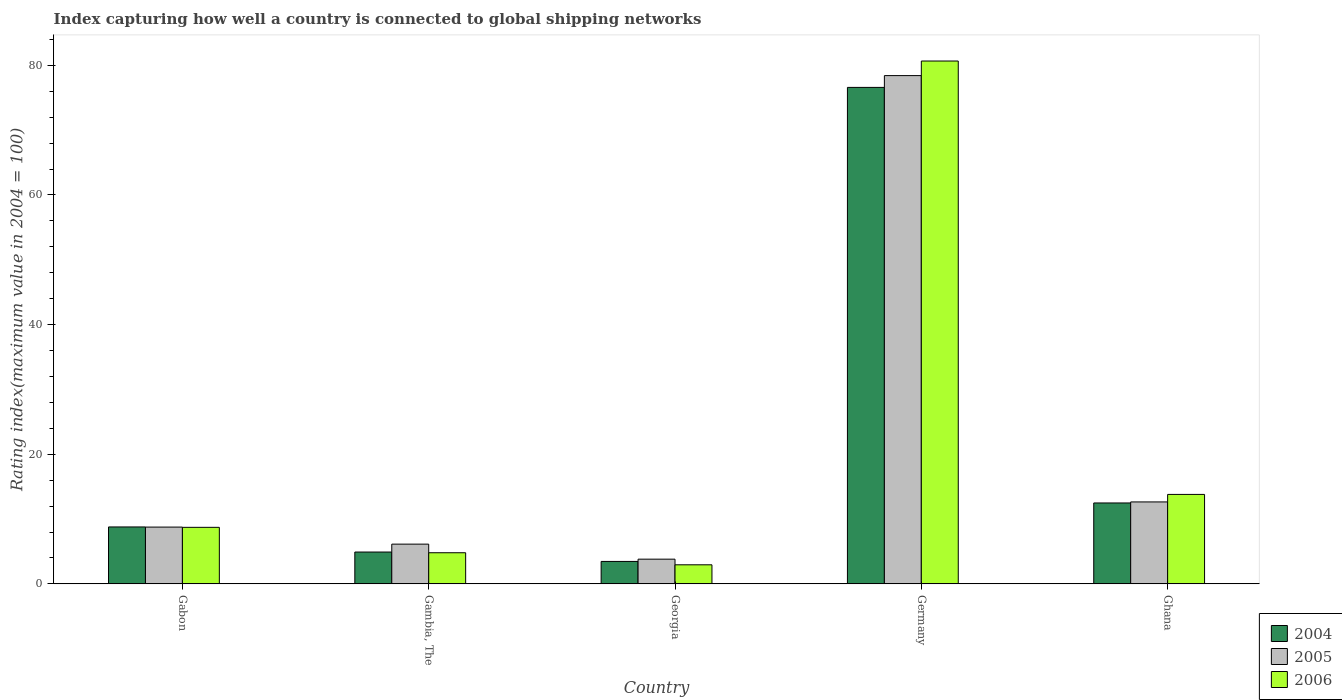How many different coloured bars are there?
Your answer should be compact. 3. How many bars are there on the 1st tick from the right?
Offer a terse response. 3. What is the label of the 1st group of bars from the left?
Your response must be concise. Gabon. What is the rating index in 2005 in Gabon?
Ensure brevity in your answer.  8.76. Across all countries, what is the maximum rating index in 2006?
Your response must be concise. 80.66. Across all countries, what is the minimum rating index in 2005?
Your answer should be very brief. 3.81. In which country was the rating index in 2005 maximum?
Your response must be concise. Germany. In which country was the rating index in 2005 minimum?
Your answer should be very brief. Georgia. What is the total rating index in 2006 in the graph?
Make the answer very short. 110.92. What is the difference between the rating index in 2004 in Gabon and that in Ghana?
Provide a short and direct response. -3.7. What is the difference between the rating index in 2004 in Georgia and the rating index in 2005 in Ghana?
Keep it short and to the point. -9.18. What is the average rating index in 2004 per country?
Provide a succinct answer. 21.24. What is the difference between the rating index of/in 2005 and rating index of/in 2006 in Gambia, The?
Your response must be concise. 1.33. What is the ratio of the rating index in 2005 in Gambia, The to that in Ghana?
Keep it short and to the point. 0.48. Is the rating index in 2006 in Gabon less than that in Germany?
Make the answer very short. Yes. Is the difference between the rating index in 2005 in Gambia, The and Georgia greater than the difference between the rating index in 2006 in Gambia, The and Georgia?
Offer a very short reply. Yes. What is the difference between the highest and the second highest rating index in 2005?
Offer a very short reply. -3.88. What is the difference between the highest and the lowest rating index in 2004?
Offer a very short reply. 73.13. Is the sum of the rating index in 2006 in Gabon and Germany greater than the maximum rating index in 2005 across all countries?
Provide a succinct answer. Yes. What does the 1st bar from the left in Germany represents?
Keep it short and to the point. 2004. Is it the case that in every country, the sum of the rating index in 2005 and rating index in 2006 is greater than the rating index in 2004?
Your answer should be very brief. Yes. How many bars are there?
Provide a succinct answer. 15. Are all the bars in the graph horizontal?
Your answer should be compact. No. How many countries are there in the graph?
Provide a short and direct response. 5. What is the difference between two consecutive major ticks on the Y-axis?
Provide a succinct answer. 20. Are the values on the major ticks of Y-axis written in scientific E-notation?
Your answer should be compact. No. Does the graph contain grids?
Offer a very short reply. No. Where does the legend appear in the graph?
Keep it short and to the point. Bottom right. How many legend labels are there?
Keep it short and to the point. 3. What is the title of the graph?
Offer a very short reply. Index capturing how well a country is connected to global shipping networks. What is the label or title of the X-axis?
Your response must be concise. Country. What is the label or title of the Y-axis?
Offer a terse response. Rating index(maximum value in 2004 = 100). What is the Rating index(maximum value in 2004 = 100) in 2004 in Gabon?
Keep it short and to the point. 8.78. What is the Rating index(maximum value in 2004 = 100) in 2005 in Gabon?
Provide a short and direct response. 8.76. What is the Rating index(maximum value in 2004 = 100) in 2006 in Gabon?
Your answer should be very brief. 8.72. What is the Rating index(maximum value in 2004 = 100) of 2004 in Gambia, The?
Offer a terse response. 4.91. What is the Rating index(maximum value in 2004 = 100) of 2005 in Gambia, The?
Provide a succinct answer. 6.13. What is the Rating index(maximum value in 2004 = 100) in 2004 in Georgia?
Keep it short and to the point. 3.46. What is the Rating index(maximum value in 2004 = 100) of 2005 in Georgia?
Ensure brevity in your answer.  3.81. What is the Rating index(maximum value in 2004 = 100) of 2006 in Georgia?
Offer a terse response. 2.94. What is the Rating index(maximum value in 2004 = 100) of 2004 in Germany?
Offer a very short reply. 76.59. What is the Rating index(maximum value in 2004 = 100) of 2005 in Germany?
Offer a very short reply. 78.41. What is the Rating index(maximum value in 2004 = 100) in 2006 in Germany?
Give a very brief answer. 80.66. What is the Rating index(maximum value in 2004 = 100) of 2004 in Ghana?
Give a very brief answer. 12.48. What is the Rating index(maximum value in 2004 = 100) of 2005 in Ghana?
Ensure brevity in your answer.  12.64. Across all countries, what is the maximum Rating index(maximum value in 2004 = 100) in 2004?
Provide a short and direct response. 76.59. Across all countries, what is the maximum Rating index(maximum value in 2004 = 100) in 2005?
Make the answer very short. 78.41. Across all countries, what is the maximum Rating index(maximum value in 2004 = 100) in 2006?
Make the answer very short. 80.66. Across all countries, what is the minimum Rating index(maximum value in 2004 = 100) in 2004?
Your answer should be compact. 3.46. Across all countries, what is the minimum Rating index(maximum value in 2004 = 100) of 2005?
Offer a very short reply. 3.81. Across all countries, what is the minimum Rating index(maximum value in 2004 = 100) in 2006?
Give a very brief answer. 2.94. What is the total Rating index(maximum value in 2004 = 100) of 2004 in the graph?
Your answer should be compact. 106.22. What is the total Rating index(maximum value in 2004 = 100) in 2005 in the graph?
Your response must be concise. 109.75. What is the total Rating index(maximum value in 2004 = 100) of 2006 in the graph?
Keep it short and to the point. 110.92. What is the difference between the Rating index(maximum value in 2004 = 100) of 2004 in Gabon and that in Gambia, The?
Offer a terse response. 3.87. What is the difference between the Rating index(maximum value in 2004 = 100) in 2005 in Gabon and that in Gambia, The?
Your answer should be compact. 2.63. What is the difference between the Rating index(maximum value in 2004 = 100) in 2006 in Gabon and that in Gambia, The?
Your response must be concise. 3.92. What is the difference between the Rating index(maximum value in 2004 = 100) in 2004 in Gabon and that in Georgia?
Your answer should be very brief. 5.32. What is the difference between the Rating index(maximum value in 2004 = 100) of 2005 in Gabon and that in Georgia?
Give a very brief answer. 4.95. What is the difference between the Rating index(maximum value in 2004 = 100) of 2006 in Gabon and that in Georgia?
Your response must be concise. 5.78. What is the difference between the Rating index(maximum value in 2004 = 100) in 2004 in Gabon and that in Germany?
Your response must be concise. -67.81. What is the difference between the Rating index(maximum value in 2004 = 100) of 2005 in Gabon and that in Germany?
Provide a short and direct response. -69.65. What is the difference between the Rating index(maximum value in 2004 = 100) of 2006 in Gabon and that in Germany?
Your answer should be very brief. -71.94. What is the difference between the Rating index(maximum value in 2004 = 100) in 2004 in Gabon and that in Ghana?
Your answer should be very brief. -3.7. What is the difference between the Rating index(maximum value in 2004 = 100) in 2005 in Gabon and that in Ghana?
Give a very brief answer. -3.88. What is the difference between the Rating index(maximum value in 2004 = 100) in 2006 in Gabon and that in Ghana?
Ensure brevity in your answer.  -5.08. What is the difference between the Rating index(maximum value in 2004 = 100) of 2004 in Gambia, The and that in Georgia?
Offer a terse response. 1.45. What is the difference between the Rating index(maximum value in 2004 = 100) of 2005 in Gambia, The and that in Georgia?
Provide a short and direct response. 2.32. What is the difference between the Rating index(maximum value in 2004 = 100) of 2006 in Gambia, The and that in Georgia?
Your answer should be very brief. 1.86. What is the difference between the Rating index(maximum value in 2004 = 100) of 2004 in Gambia, The and that in Germany?
Make the answer very short. -71.68. What is the difference between the Rating index(maximum value in 2004 = 100) in 2005 in Gambia, The and that in Germany?
Ensure brevity in your answer.  -72.28. What is the difference between the Rating index(maximum value in 2004 = 100) of 2006 in Gambia, The and that in Germany?
Ensure brevity in your answer.  -75.86. What is the difference between the Rating index(maximum value in 2004 = 100) in 2004 in Gambia, The and that in Ghana?
Your response must be concise. -7.57. What is the difference between the Rating index(maximum value in 2004 = 100) in 2005 in Gambia, The and that in Ghana?
Ensure brevity in your answer.  -6.51. What is the difference between the Rating index(maximum value in 2004 = 100) in 2006 in Gambia, The and that in Ghana?
Give a very brief answer. -9. What is the difference between the Rating index(maximum value in 2004 = 100) of 2004 in Georgia and that in Germany?
Ensure brevity in your answer.  -73.13. What is the difference between the Rating index(maximum value in 2004 = 100) in 2005 in Georgia and that in Germany?
Offer a very short reply. -74.6. What is the difference between the Rating index(maximum value in 2004 = 100) in 2006 in Georgia and that in Germany?
Provide a short and direct response. -77.72. What is the difference between the Rating index(maximum value in 2004 = 100) in 2004 in Georgia and that in Ghana?
Your answer should be very brief. -9.02. What is the difference between the Rating index(maximum value in 2004 = 100) in 2005 in Georgia and that in Ghana?
Ensure brevity in your answer.  -8.83. What is the difference between the Rating index(maximum value in 2004 = 100) in 2006 in Georgia and that in Ghana?
Make the answer very short. -10.86. What is the difference between the Rating index(maximum value in 2004 = 100) in 2004 in Germany and that in Ghana?
Provide a succinct answer. 64.11. What is the difference between the Rating index(maximum value in 2004 = 100) of 2005 in Germany and that in Ghana?
Your answer should be very brief. 65.77. What is the difference between the Rating index(maximum value in 2004 = 100) of 2006 in Germany and that in Ghana?
Provide a short and direct response. 66.86. What is the difference between the Rating index(maximum value in 2004 = 100) of 2004 in Gabon and the Rating index(maximum value in 2004 = 100) of 2005 in Gambia, The?
Ensure brevity in your answer.  2.65. What is the difference between the Rating index(maximum value in 2004 = 100) of 2004 in Gabon and the Rating index(maximum value in 2004 = 100) of 2006 in Gambia, The?
Provide a short and direct response. 3.98. What is the difference between the Rating index(maximum value in 2004 = 100) in 2005 in Gabon and the Rating index(maximum value in 2004 = 100) in 2006 in Gambia, The?
Keep it short and to the point. 3.96. What is the difference between the Rating index(maximum value in 2004 = 100) of 2004 in Gabon and the Rating index(maximum value in 2004 = 100) of 2005 in Georgia?
Provide a succinct answer. 4.97. What is the difference between the Rating index(maximum value in 2004 = 100) of 2004 in Gabon and the Rating index(maximum value in 2004 = 100) of 2006 in Georgia?
Offer a terse response. 5.84. What is the difference between the Rating index(maximum value in 2004 = 100) of 2005 in Gabon and the Rating index(maximum value in 2004 = 100) of 2006 in Georgia?
Provide a succinct answer. 5.82. What is the difference between the Rating index(maximum value in 2004 = 100) in 2004 in Gabon and the Rating index(maximum value in 2004 = 100) in 2005 in Germany?
Offer a terse response. -69.63. What is the difference between the Rating index(maximum value in 2004 = 100) of 2004 in Gabon and the Rating index(maximum value in 2004 = 100) of 2006 in Germany?
Keep it short and to the point. -71.88. What is the difference between the Rating index(maximum value in 2004 = 100) of 2005 in Gabon and the Rating index(maximum value in 2004 = 100) of 2006 in Germany?
Keep it short and to the point. -71.9. What is the difference between the Rating index(maximum value in 2004 = 100) of 2004 in Gabon and the Rating index(maximum value in 2004 = 100) of 2005 in Ghana?
Offer a very short reply. -3.86. What is the difference between the Rating index(maximum value in 2004 = 100) in 2004 in Gabon and the Rating index(maximum value in 2004 = 100) in 2006 in Ghana?
Provide a succinct answer. -5.02. What is the difference between the Rating index(maximum value in 2004 = 100) in 2005 in Gabon and the Rating index(maximum value in 2004 = 100) in 2006 in Ghana?
Provide a short and direct response. -5.04. What is the difference between the Rating index(maximum value in 2004 = 100) in 2004 in Gambia, The and the Rating index(maximum value in 2004 = 100) in 2006 in Georgia?
Offer a terse response. 1.97. What is the difference between the Rating index(maximum value in 2004 = 100) in 2005 in Gambia, The and the Rating index(maximum value in 2004 = 100) in 2006 in Georgia?
Your answer should be very brief. 3.19. What is the difference between the Rating index(maximum value in 2004 = 100) of 2004 in Gambia, The and the Rating index(maximum value in 2004 = 100) of 2005 in Germany?
Make the answer very short. -73.5. What is the difference between the Rating index(maximum value in 2004 = 100) of 2004 in Gambia, The and the Rating index(maximum value in 2004 = 100) of 2006 in Germany?
Make the answer very short. -75.75. What is the difference between the Rating index(maximum value in 2004 = 100) of 2005 in Gambia, The and the Rating index(maximum value in 2004 = 100) of 2006 in Germany?
Offer a very short reply. -74.53. What is the difference between the Rating index(maximum value in 2004 = 100) of 2004 in Gambia, The and the Rating index(maximum value in 2004 = 100) of 2005 in Ghana?
Give a very brief answer. -7.73. What is the difference between the Rating index(maximum value in 2004 = 100) of 2004 in Gambia, The and the Rating index(maximum value in 2004 = 100) of 2006 in Ghana?
Offer a terse response. -8.89. What is the difference between the Rating index(maximum value in 2004 = 100) in 2005 in Gambia, The and the Rating index(maximum value in 2004 = 100) in 2006 in Ghana?
Give a very brief answer. -7.67. What is the difference between the Rating index(maximum value in 2004 = 100) in 2004 in Georgia and the Rating index(maximum value in 2004 = 100) in 2005 in Germany?
Give a very brief answer. -74.95. What is the difference between the Rating index(maximum value in 2004 = 100) in 2004 in Georgia and the Rating index(maximum value in 2004 = 100) in 2006 in Germany?
Provide a succinct answer. -77.2. What is the difference between the Rating index(maximum value in 2004 = 100) in 2005 in Georgia and the Rating index(maximum value in 2004 = 100) in 2006 in Germany?
Your response must be concise. -76.85. What is the difference between the Rating index(maximum value in 2004 = 100) in 2004 in Georgia and the Rating index(maximum value in 2004 = 100) in 2005 in Ghana?
Your answer should be very brief. -9.18. What is the difference between the Rating index(maximum value in 2004 = 100) in 2004 in Georgia and the Rating index(maximum value in 2004 = 100) in 2006 in Ghana?
Provide a succinct answer. -10.34. What is the difference between the Rating index(maximum value in 2004 = 100) in 2005 in Georgia and the Rating index(maximum value in 2004 = 100) in 2006 in Ghana?
Offer a very short reply. -9.99. What is the difference between the Rating index(maximum value in 2004 = 100) in 2004 in Germany and the Rating index(maximum value in 2004 = 100) in 2005 in Ghana?
Offer a terse response. 63.95. What is the difference between the Rating index(maximum value in 2004 = 100) of 2004 in Germany and the Rating index(maximum value in 2004 = 100) of 2006 in Ghana?
Provide a short and direct response. 62.79. What is the difference between the Rating index(maximum value in 2004 = 100) in 2005 in Germany and the Rating index(maximum value in 2004 = 100) in 2006 in Ghana?
Provide a succinct answer. 64.61. What is the average Rating index(maximum value in 2004 = 100) in 2004 per country?
Make the answer very short. 21.24. What is the average Rating index(maximum value in 2004 = 100) in 2005 per country?
Your answer should be compact. 21.95. What is the average Rating index(maximum value in 2004 = 100) in 2006 per country?
Your answer should be compact. 22.18. What is the difference between the Rating index(maximum value in 2004 = 100) in 2004 and Rating index(maximum value in 2004 = 100) in 2005 in Gambia, The?
Your response must be concise. -1.22. What is the difference between the Rating index(maximum value in 2004 = 100) of 2004 and Rating index(maximum value in 2004 = 100) of 2006 in Gambia, The?
Ensure brevity in your answer.  0.11. What is the difference between the Rating index(maximum value in 2004 = 100) in 2005 and Rating index(maximum value in 2004 = 100) in 2006 in Gambia, The?
Your answer should be compact. 1.33. What is the difference between the Rating index(maximum value in 2004 = 100) in 2004 and Rating index(maximum value in 2004 = 100) in 2005 in Georgia?
Your answer should be compact. -0.35. What is the difference between the Rating index(maximum value in 2004 = 100) in 2004 and Rating index(maximum value in 2004 = 100) in 2006 in Georgia?
Offer a very short reply. 0.52. What is the difference between the Rating index(maximum value in 2004 = 100) of 2005 and Rating index(maximum value in 2004 = 100) of 2006 in Georgia?
Keep it short and to the point. 0.87. What is the difference between the Rating index(maximum value in 2004 = 100) in 2004 and Rating index(maximum value in 2004 = 100) in 2005 in Germany?
Your answer should be very brief. -1.82. What is the difference between the Rating index(maximum value in 2004 = 100) of 2004 and Rating index(maximum value in 2004 = 100) of 2006 in Germany?
Ensure brevity in your answer.  -4.07. What is the difference between the Rating index(maximum value in 2004 = 100) of 2005 and Rating index(maximum value in 2004 = 100) of 2006 in Germany?
Give a very brief answer. -2.25. What is the difference between the Rating index(maximum value in 2004 = 100) of 2004 and Rating index(maximum value in 2004 = 100) of 2005 in Ghana?
Your response must be concise. -0.16. What is the difference between the Rating index(maximum value in 2004 = 100) of 2004 and Rating index(maximum value in 2004 = 100) of 2006 in Ghana?
Provide a short and direct response. -1.32. What is the difference between the Rating index(maximum value in 2004 = 100) of 2005 and Rating index(maximum value in 2004 = 100) of 2006 in Ghana?
Your answer should be compact. -1.16. What is the ratio of the Rating index(maximum value in 2004 = 100) in 2004 in Gabon to that in Gambia, The?
Keep it short and to the point. 1.79. What is the ratio of the Rating index(maximum value in 2004 = 100) of 2005 in Gabon to that in Gambia, The?
Offer a terse response. 1.43. What is the ratio of the Rating index(maximum value in 2004 = 100) of 2006 in Gabon to that in Gambia, The?
Offer a very short reply. 1.82. What is the ratio of the Rating index(maximum value in 2004 = 100) in 2004 in Gabon to that in Georgia?
Your response must be concise. 2.54. What is the ratio of the Rating index(maximum value in 2004 = 100) of 2005 in Gabon to that in Georgia?
Your response must be concise. 2.3. What is the ratio of the Rating index(maximum value in 2004 = 100) of 2006 in Gabon to that in Georgia?
Your answer should be very brief. 2.97. What is the ratio of the Rating index(maximum value in 2004 = 100) in 2004 in Gabon to that in Germany?
Your answer should be compact. 0.11. What is the ratio of the Rating index(maximum value in 2004 = 100) of 2005 in Gabon to that in Germany?
Offer a very short reply. 0.11. What is the ratio of the Rating index(maximum value in 2004 = 100) in 2006 in Gabon to that in Germany?
Offer a very short reply. 0.11. What is the ratio of the Rating index(maximum value in 2004 = 100) of 2004 in Gabon to that in Ghana?
Offer a terse response. 0.7. What is the ratio of the Rating index(maximum value in 2004 = 100) of 2005 in Gabon to that in Ghana?
Make the answer very short. 0.69. What is the ratio of the Rating index(maximum value in 2004 = 100) in 2006 in Gabon to that in Ghana?
Provide a succinct answer. 0.63. What is the ratio of the Rating index(maximum value in 2004 = 100) of 2004 in Gambia, The to that in Georgia?
Ensure brevity in your answer.  1.42. What is the ratio of the Rating index(maximum value in 2004 = 100) in 2005 in Gambia, The to that in Georgia?
Ensure brevity in your answer.  1.61. What is the ratio of the Rating index(maximum value in 2004 = 100) in 2006 in Gambia, The to that in Georgia?
Provide a short and direct response. 1.63. What is the ratio of the Rating index(maximum value in 2004 = 100) of 2004 in Gambia, The to that in Germany?
Make the answer very short. 0.06. What is the ratio of the Rating index(maximum value in 2004 = 100) of 2005 in Gambia, The to that in Germany?
Your answer should be very brief. 0.08. What is the ratio of the Rating index(maximum value in 2004 = 100) in 2006 in Gambia, The to that in Germany?
Make the answer very short. 0.06. What is the ratio of the Rating index(maximum value in 2004 = 100) of 2004 in Gambia, The to that in Ghana?
Ensure brevity in your answer.  0.39. What is the ratio of the Rating index(maximum value in 2004 = 100) in 2005 in Gambia, The to that in Ghana?
Offer a very short reply. 0.48. What is the ratio of the Rating index(maximum value in 2004 = 100) in 2006 in Gambia, The to that in Ghana?
Offer a terse response. 0.35. What is the ratio of the Rating index(maximum value in 2004 = 100) of 2004 in Georgia to that in Germany?
Provide a succinct answer. 0.05. What is the ratio of the Rating index(maximum value in 2004 = 100) of 2005 in Georgia to that in Germany?
Provide a short and direct response. 0.05. What is the ratio of the Rating index(maximum value in 2004 = 100) of 2006 in Georgia to that in Germany?
Ensure brevity in your answer.  0.04. What is the ratio of the Rating index(maximum value in 2004 = 100) in 2004 in Georgia to that in Ghana?
Offer a terse response. 0.28. What is the ratio of the Rating index(maximum value in 2004 = 100) in 2005 in Georgia to that in Ghana?
Offer a very short reply. 0.3. What is the ratio of the Rating index(maximum value in 2004 = 100) of 2006 in Georgia to that in Ghana?
Ensure brevity in your answer.  0.21. What is the ratio of the Rating index(maximum value in 2004 = 100) in 2004 in Germany to that in Ghana?
Provide a succinct answer. 6.14. What is the ratio of the Rating index(maximum value in 2004 = 100) of 2005 in Germany to that in Ghana?
Provide a short and direct response. 6.2. What is the ratio of the Rating index(maximum value in 2004 = 100) in 2006 in Germany to that in Ghana?
Your answer should be compact. 5.84. What is the difference between the highest and the second highest Rating index(maximum value in 2004 = 100) in 2004?
Your response must be concise. 64.11. What is the difference between the highest and the second highest Rating index(maximum value in 2004 = 100) of 2005?
Give a very brief answer. 65.77. What is the difference between the highest and the second highest Rating index(maximum value in 2004 = 100) in 2006?
Offer a terse response. 66.86. What is the difference between the highest and the lowest Rating index(maximum value in 2004 = 100) in 2004?
Give a very brief answer. 73.13. What is the difference between the highest and the lowest Rating index(maximum value in 2004 = 100) of 2005?
Your answer should be compact. 74.6. What is the difference between the highest and the lowest Rating index(maximum value in 2004 = 100) of 2006?
Provide a succinct answer. 77.72. 